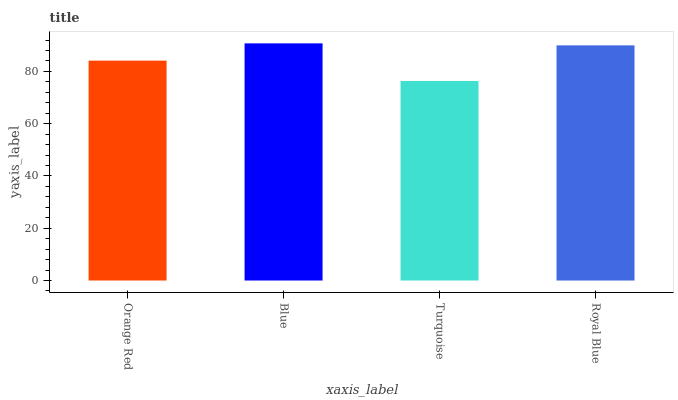Is Turquoise the minimum?
Answer yes or no. Yes. Is Blue the maximum?
Answer yes or no. Yes. Is Blue the minimum?
Answer yes or no. No. Is Turquoise the maximum?
Answer yes or no. No. Is Blue greater than Turquoise?
Answer yes or no. Yes. Is Turquoise less than Blue?
Answer yes or no. Yes. Is Turquoise greater than Blue?
Answer yes or no. No. Is Blue less than Turquoise?
Answer yes or no. No. Is Royal Blue the high median?
Answer yes or no. Yes. Is Orange Red the low median?
Answer yes or no. Yes. Is Blue the high median?
Answer yes or no. No. Is Royal Blue the low median?
Answer yes or no. No. 